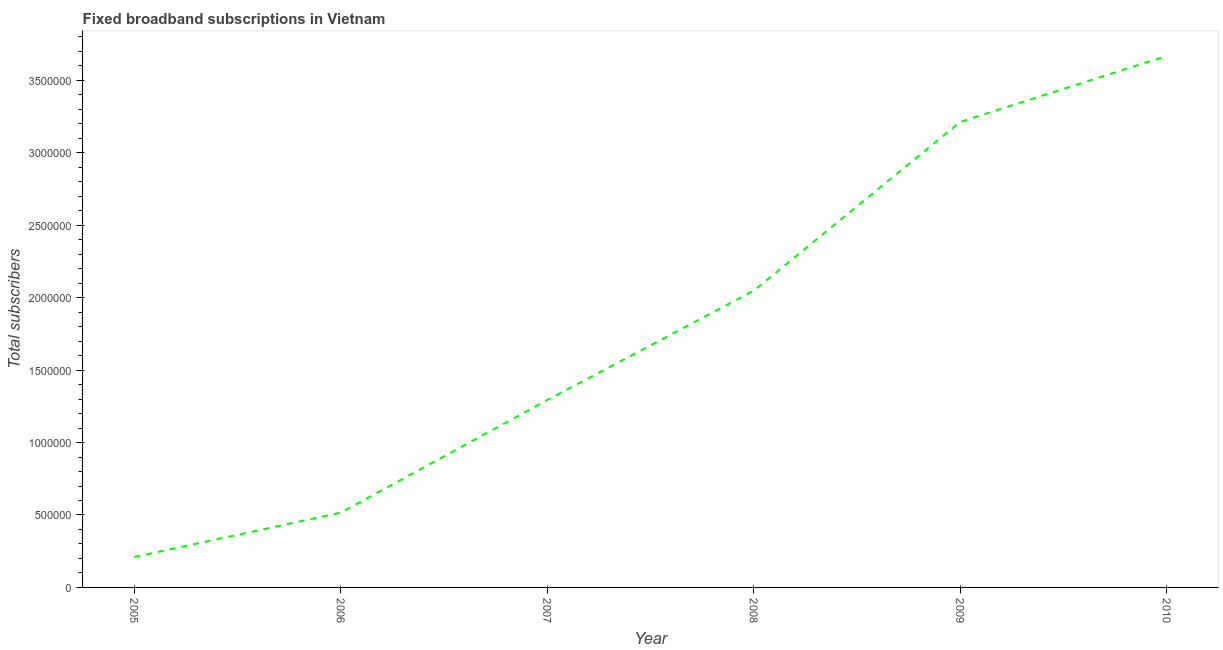What is the total number of fixed broadband subscriptions in 2008?
Your answer should be compact. 2.05e+06. Across all years, what is the maximum total number of fixed broadband subscriptions?
Give a very brief answer. 3.67e+06. Across all years, what is the minimum total number of fixed broadband subscriptions?
Offer a very short reply. 2.10e+05. In which year was the total number of fixed broadband subscriptions maximum?
Your answer should be very brief. 2010. What is the sum of the total number of fixed broadband subscriptions?
Offer a very short reply. 1.10e+07. What is the difference between the total number of fixed broadband subscriptions in 2005 and 2007?
Keep it short and to the point. -1.08e+06. What is the average total number of fixed broadband subscriptions per year?
Offer a terse response. 1.83e+06. What is the median total number of fixed broadband subscriptions?
Make the answer very short. 1.67e+06. Do a majority of the years between 2006 and 2008 (inclusive) have total number of fixed broadband subscriptions greater than 2100000 ?
Your response must be concise. No. What is the ratio of the total number of fixed broadband subscriptions in 2005 to that in 2010?
Provide a short and direct response. 0.06. Is the difference between the total number of fixed broadband subscriptions in 2007 and 2010 greater than the difference between any two years?
Keep it short and to the point. No. What is the difference between the highest and the second highest total number of fixed broadband subscriptions?
Your response must be concise. 4.55e+05. Is the sum of the total number of fixed broadband subscriptions in 2005 and 2008 greater than the maximum total number of fixed broadband subscriptions across all years?
Provide a short and direct response. No. What is the difference between the highest and the lowest total number of fixed broadband subscriptions?
Ensure brevity in your answer.  3.46e+06. Does the total number of fixed broadband subscriptions monotonically increase over the years?
Your response must be concise. Yes. How many lines are there?
Ensure brevity in your answer.  1. How many years are there in the graph?
Ensure brevity in your answer.  6. Are the values on the major ticks of Y-axis written in scientific E-notation?
Keep it short and to the point. No. Does the graph contain any zero values?
Your response must be concise. No. What is the title of the graph?
Your response must be concise. Fixed broadband subscriptions in Vietnam. What is the label or title of the X-axis?
Provide a succinct answer. Year. What is the label or title of the Y-axis?
Your answer should be very brief. Total subscribers. What is the Total subscribers of 2005?
Give a very brief answer. 2.10e+05. What is the Total subscribers of 2006?
Offer a very short reply. 5.17e+05. What is the Total subscribers of 2007?
Give a very brief answer. 1.29e+06. What is the Total subscribers of 2008?
Offer a terse response. 2.05e+06. What is the Total subscribers in 2009?
Provide a short and direct response. 3.21e+06. What is the Total subscribers in 2010?
Keep it short and to the point. 3.67e+06. What is the difference between the Total subscribers in 2005 and 2006?
Ensure brevity in your answer.  -3.07e+05. What is the difference between the Total subscribers in 2005 and 2007?
Keep it short and to the point. -1.08e+06. What is the difference between the Total subscribers in 2005 and 2008?
Make the answer very short. -1.84e+06. What is the difference between the Total subscribers in 2005 and 2009?
Your answer should be very brief. -3.00e+06. What is the difference between the Total subscribers in 2005 and 2010?
Give a very brief answer. -3.46e+06. What is the difference between the Total subscribers in 2006 and 2007?
Provide a succinct answer. -7.78e+05. What is the difference between the Total subscribers in 2006 and 2008?
Ensure brevity in your answer.  -1.53e+06. What is the difference between the Total subscribers in 2006 and 2009?
Give a very brief answer. -2.70e+06. What is the difference between the Total subscribers in 2006 and 2010?
Provide a short and direct response. -3.15e+06. What is the difference between the Total subscribers in 2007 and 2008?
Ensure brevity in your answer.  -7.55e+05. What is the difference between the Total subscribers in 2007 and 2009?
Provide a succinct answer. -1.92e+06. What is the difference between the Total subscribers in 2007 and 2010?
Your response must be concise. -2.38e+06. What is the difference between the Total subscribers in 2008 and 2009?
Offer a terse response. -1.17e+06. What is the difference between the Total subscribers in 2008 and 2010?
Your response must be concise. -1.62e+06. What is the difference between the Total subscribers in 2009 and 2010?
Your answer should be very brief. -4.55e+05. What is the ratio of the Total subscribers in 2005 to that in 2006?
Provide a succinct answer. 0.41. What is the ratio of the Total subscribers in 2005 to that in 2007?
Your answer should be very brief. 0.16. What is the ratio of the Total subscribers in 2005 to that in 2008?
Provide a short and direct response. 0.1. What is the ratio of the Total subscribers in 2005 to that in 2009?
Your answer should be compact. 0.07. What is the ratio of the Total subscribers in 2005 to that in 2010?
Give a very brief answer. 0.06. What is the ratio of the Total subscribers in 2006 to that in 2007?
Your answer should be very brief. 0.4. What is the ratio of the Total subscribers in 2006 to that in 2008?
Ensure brevity in your answer.  0.25. What is the ratio of the Total subscribers in 2006 to that in 2009?
Provide a short and direct response. 0.16. What is the ratio of the Total subscribers in 2006 to that in 2010?
Your answer should be compact. 0.14. What is the ratio of the Total subscribers in 2007 to that in 2008?
Your answer should be compact. 0.63. What is the ratio of the Total subscribers in 2007 to that in 2009?
Provide a short and direct response. 0.4. What is the ratio of the Total subscribers in 2007 to that in 2010?
Provide a succinct answer. 0.35. What is the ratio of the Total subscribers in 2008 to that in 2009?
Keep it short and to the point. 0.64. What is the ratio of the Total subscribers in 2008 to that in 2010?
Ensure brevity in your answer.  0.56. What is the ratio of the Total subscribers in 2009 to that in 2010?
Offer a very short reply. 0.88. 